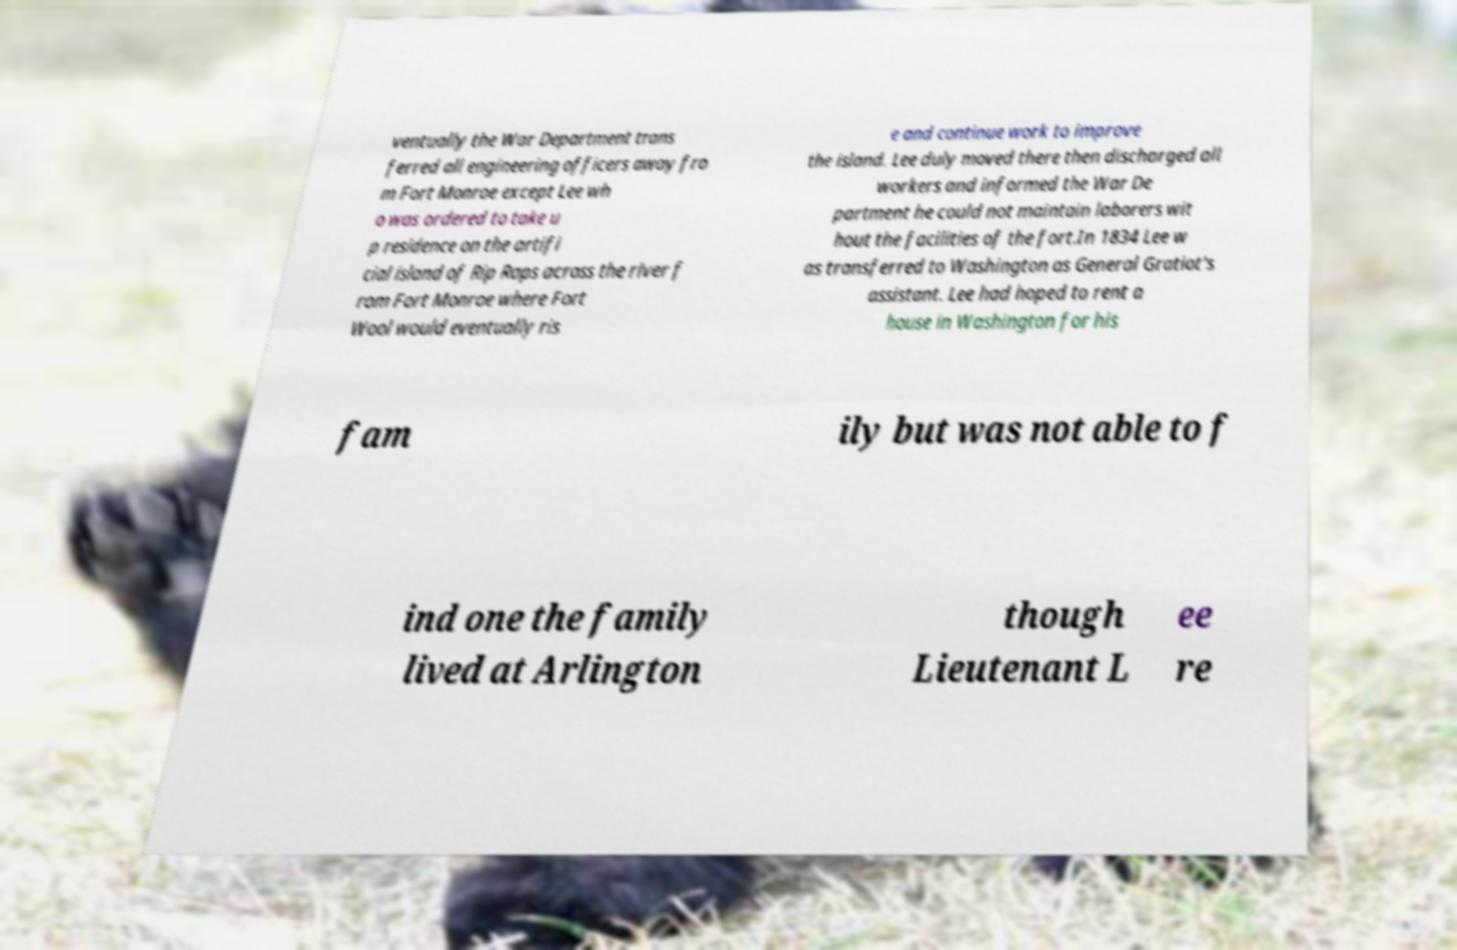Please read and relay the text visible in this image. What does it say? ventually the War Department trans ferred all engineering officers away fro m Fort Monroe except Lee wh o was ordered to take u p residence on the artifi cial island of Rip Raps across the river f rom Fort Monroe where Fort Wool would eventually ris e and continue work to improve the island. Lee duly moved there then discharged all workers and informed the War De partment he could not maintain laborers wit hout the facilities of the fort.In 1834 Lee w as transferred to Washington as General Gratiot's assistant. Lee had hoped to rent a house in Washington for his fam ily but was not able to f ind one the family lived at Arlington though Lieutenant L ee re 